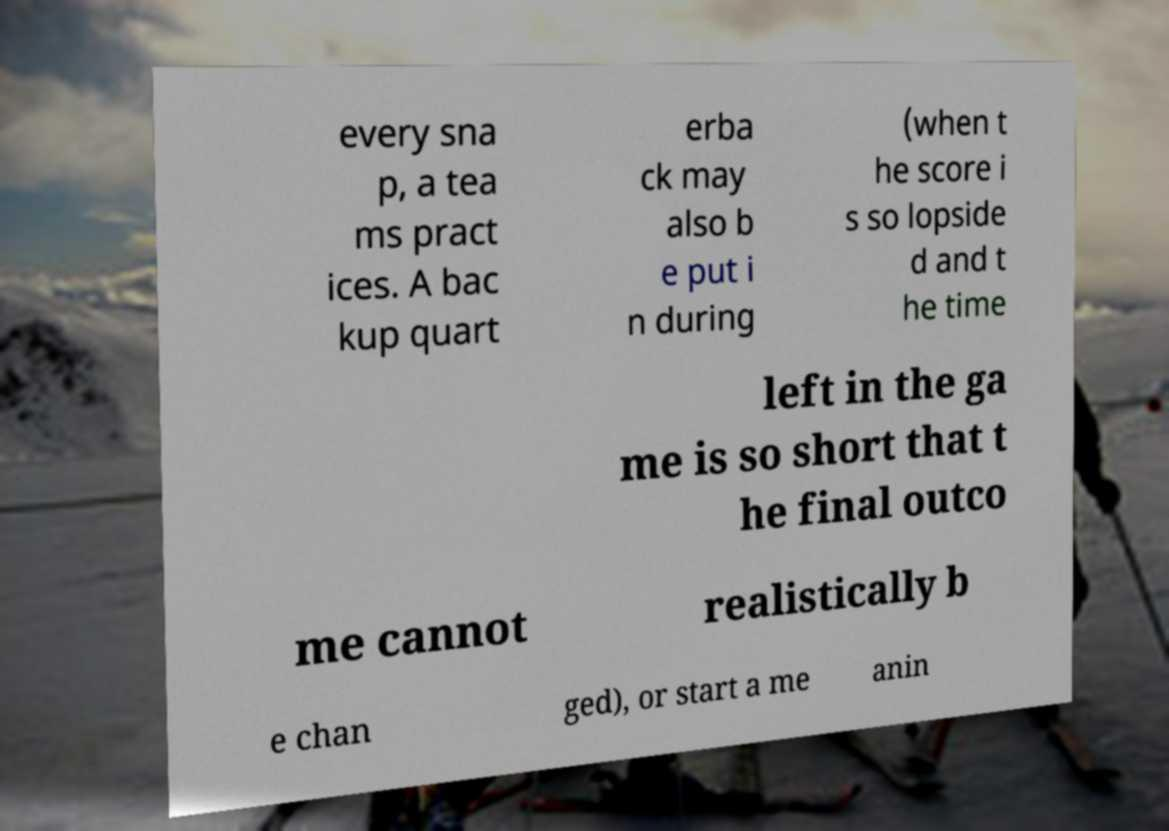Can you read and provide the text displayed in the image?This photo seems to have some interesting text. Can you extract and type it out for me? every sna p, a tea ms pract ices. A bac kup quart erba ck may also b e put i n during (when t he score i s so lopside d and t he time left in the ga me is so short that t he final outco me cannot realistically b e chan ged), or start a me anin 